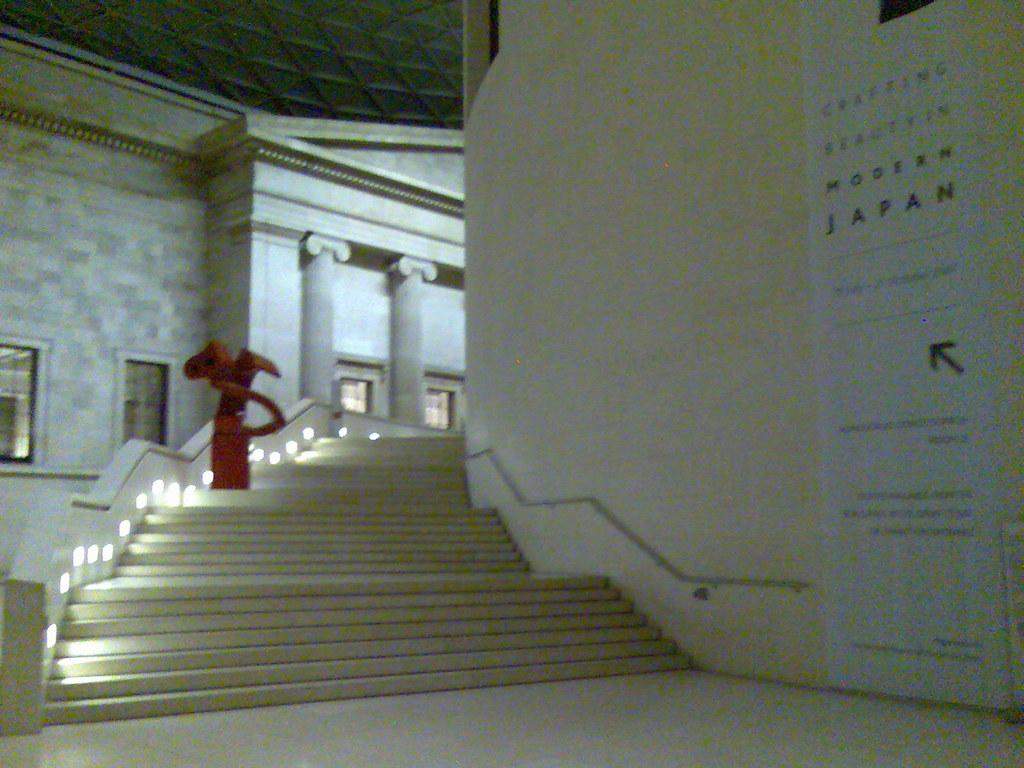What type of structure is present in the image? There is a staircase in the image. What is the color of the staircase? The staircase is white in color. Are there any additional features on the staircase? Yes, there are lights on the staircase. How many hands are visible on the staircase in the image? There are no hands visible on the staircase in the image. What type of system is being used to power the lights on the staircase? The provided facts do not mention any specific system for powering the lights on the staircase. 